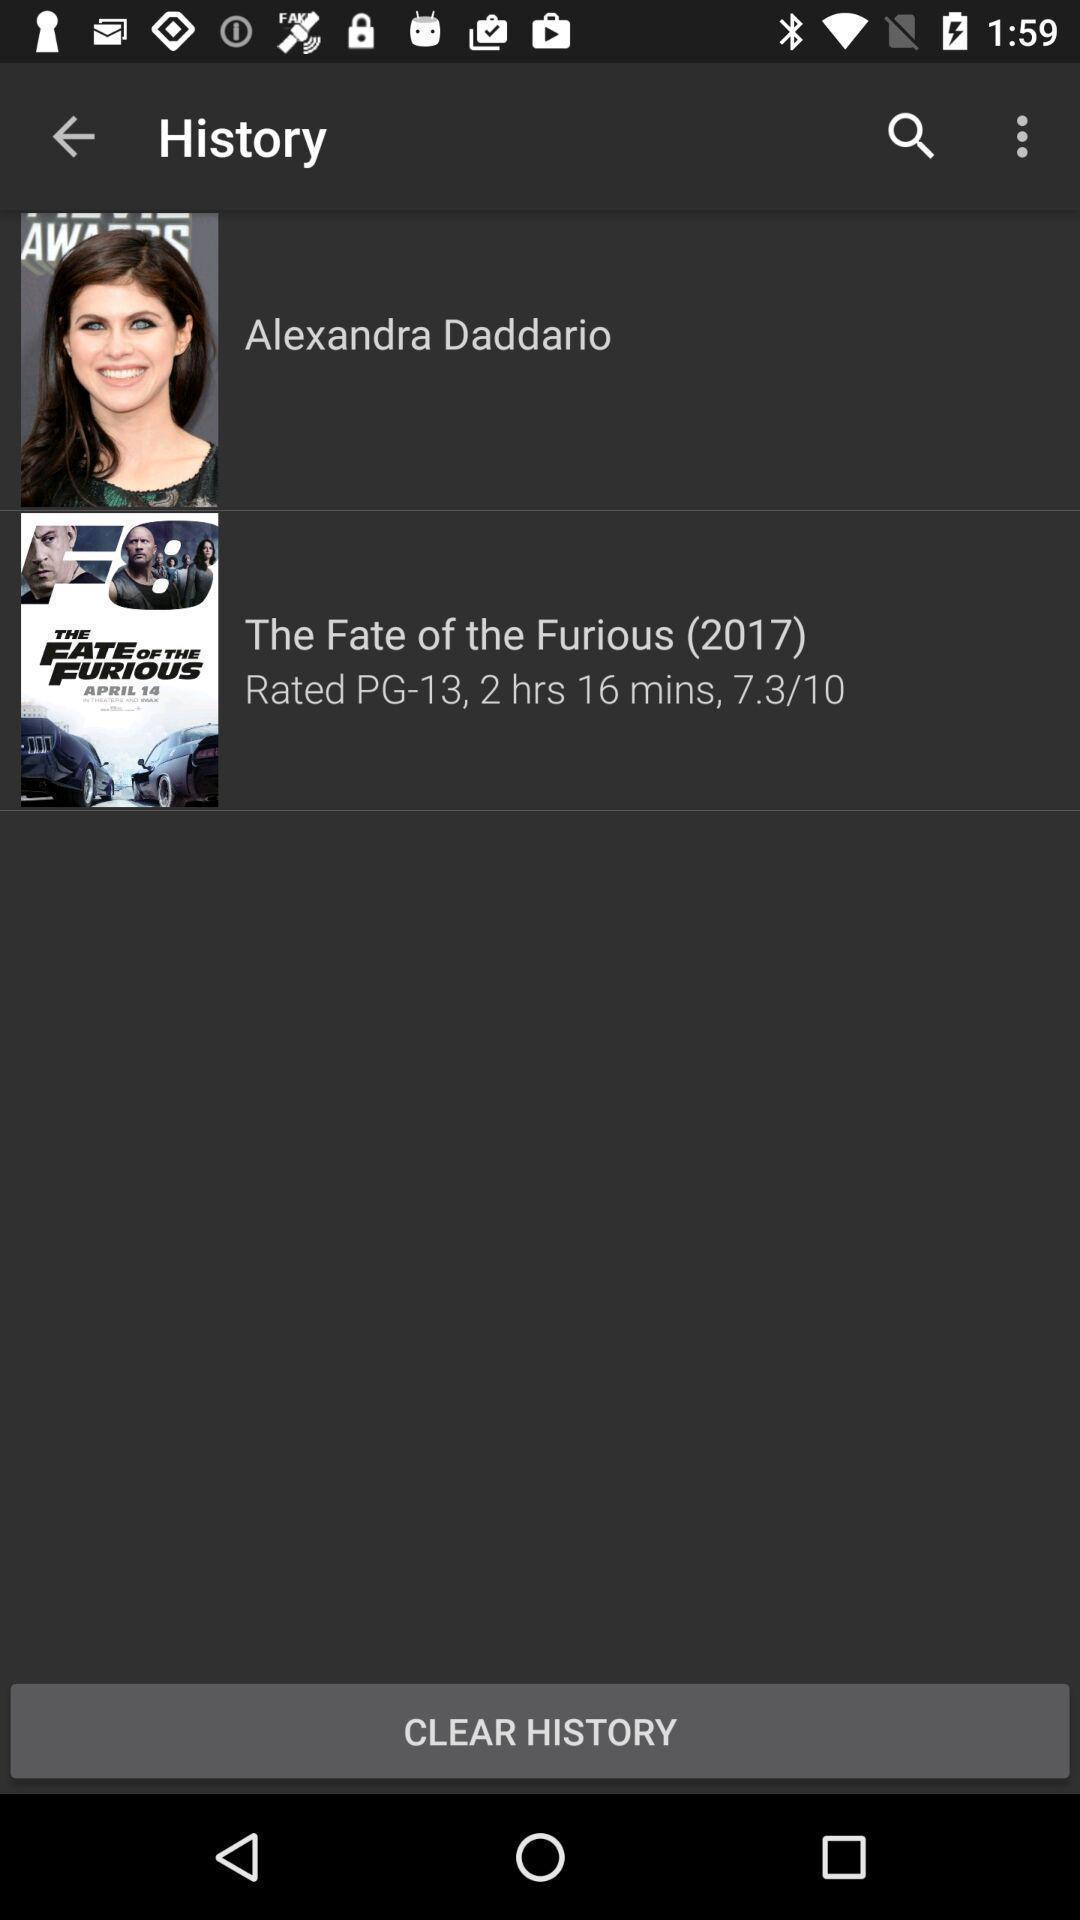Give me a summary of this screen capture. Page showing history page of an entertainment application. 